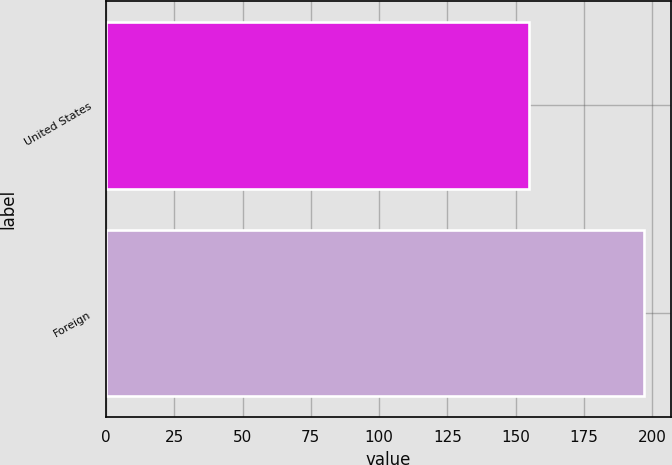<chart> <loc_0><loc_0><loc_500><loc_500><bar_chart><fcel>United States<fcel>Foreign<nl><fcel>155<fcel>197<nl></chart> 